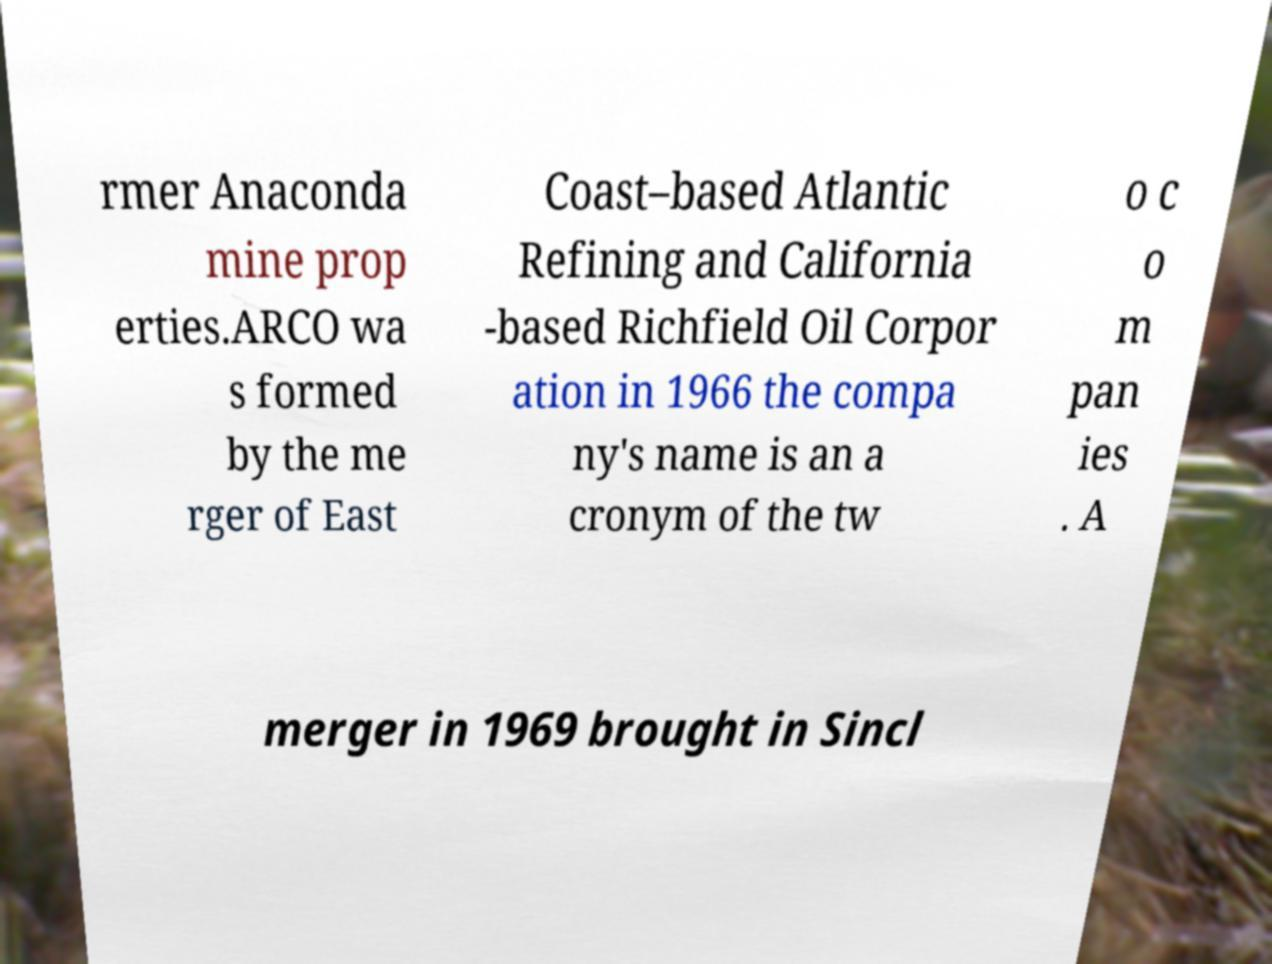Please read and relay the text visible in this image. What does it say? rmer Anaconda mine prop erties.ARCO wa s formed by the me rger of East Coast–based Atlantic Refining and California -based Richfield Oil Corpor ation in 1966 the compa ny's name is an a cronym of the tw o c o m pan ies . A merger in 1969 brought in Sincl 